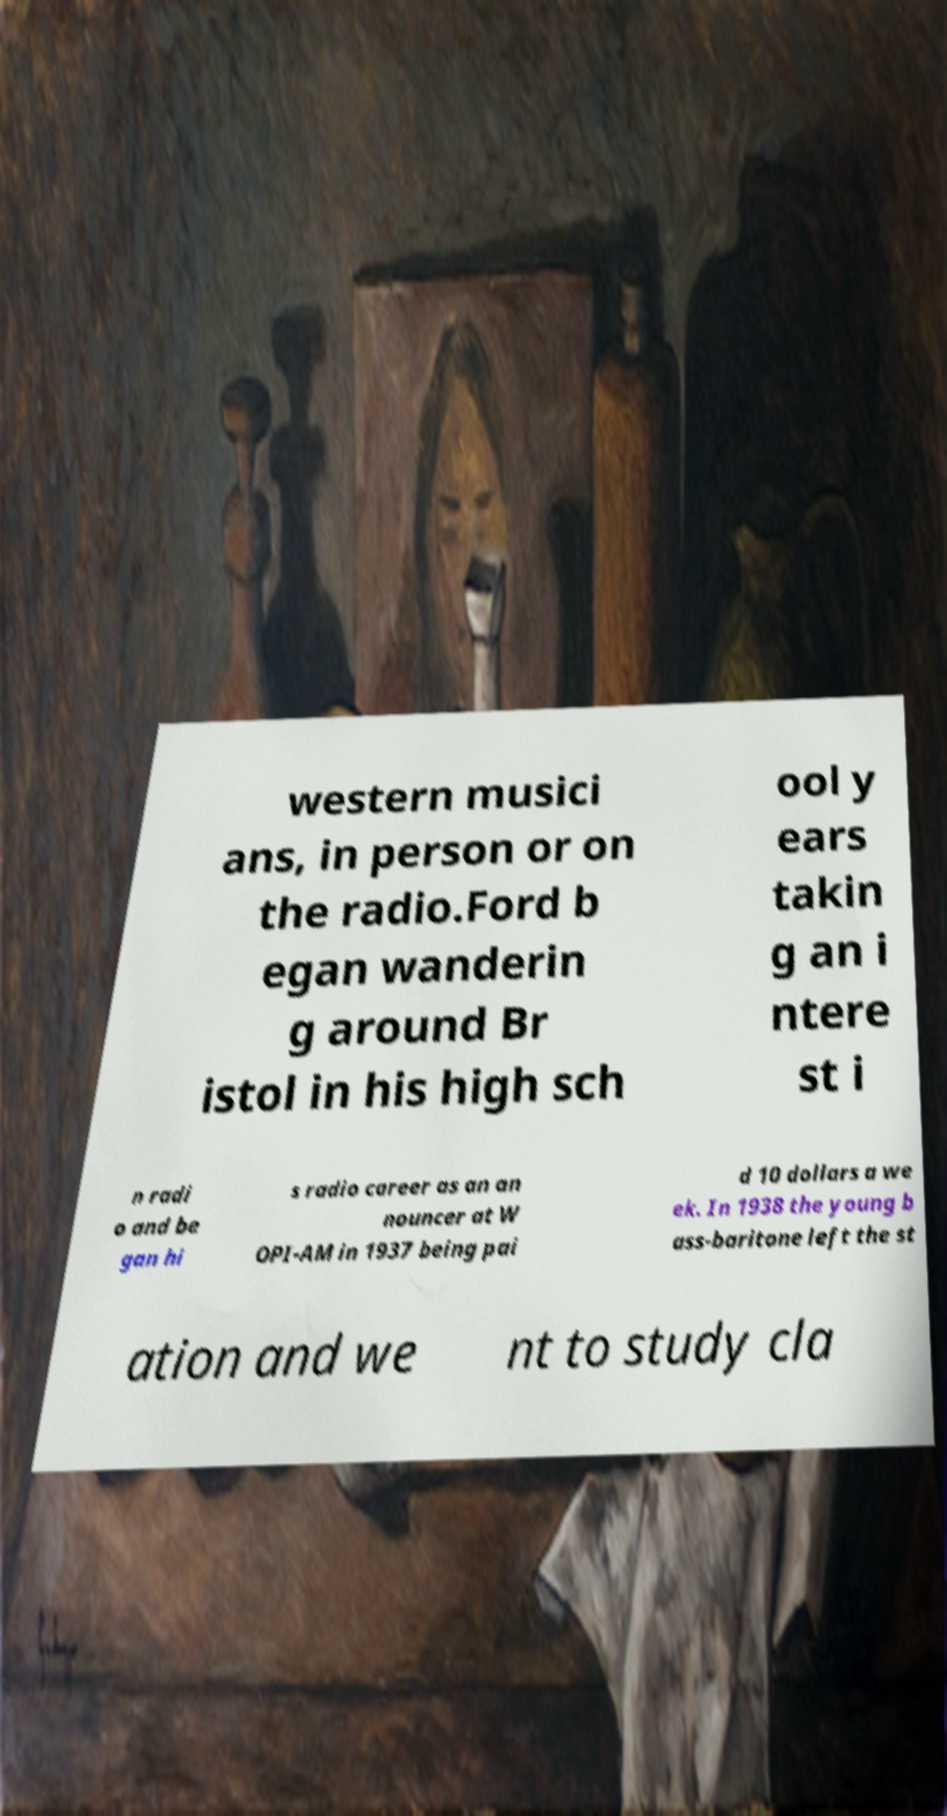For documentation purposes, I need the text within this image transcribed. Could you provide that? western musici ans, in person or on the radio.Ford b egan wanderin g around Br istol in his high sch ool y ears takin g an i ntere st i n radi o and be gan hi s radio career as an an nouncer at W OPI-AM in 1937 being pai d 10 dollars a we ek. In 1938 the young b ass-baritone left the st ation and we nt to study cla 